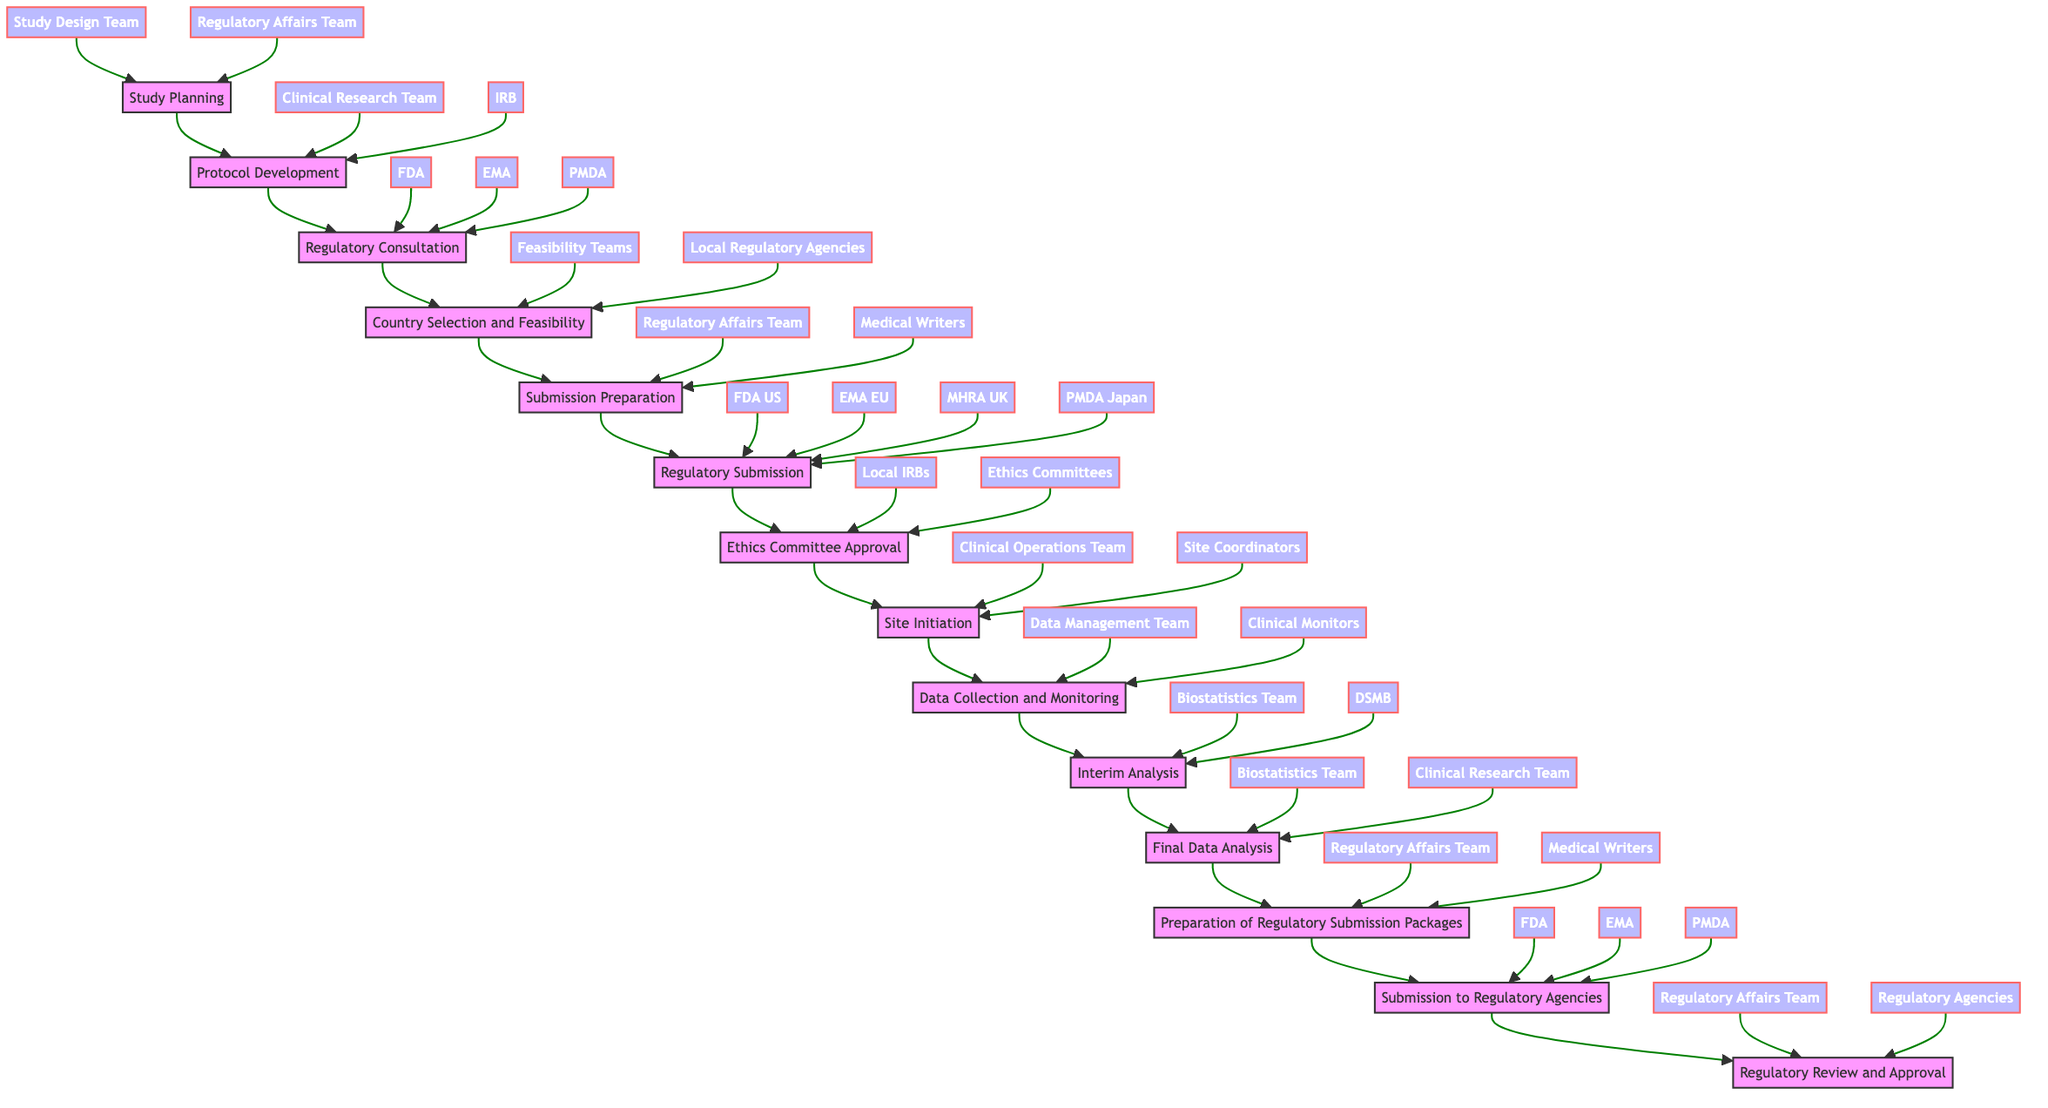What is the first action in the workflow? The first action in the workflow is "Define objectives and endpoints," which is indicated under "Study Planning."
Answer: Define objectives and endpoints How many entities are involved in the "Regulatory Consultation"? The diagram shows three entities involved in the "Regulatory Consultation," which are FDA, EMA, and PMDA.
Answer: Three What follows "Interim Analysis" in the workflow? "Final Data Analysis" directly follows "Interim Analysis" in the flow chart, creating a sequence between the two actions.
Answer: Final Data Analysis Which team is responsible for "Preparation of Regulatory Submission Packages"? The teams responsible for this action are the Regulatory Affairs Team and Medical Writers, as stated in the node for that action.
Answer: Regulatory Affairs Team, Medical Writers Which action comes after "Submission Preparation"? The action "Regulatory Submission" comes directly after "Submission Preparation" in the flow, indicating the order of tasks in the workflow.
Answer: Regulatory Submission What are the two entities involved in "Site Initiation"? The two entities involved are the Clinical Operations Team and Site Coordinators, as noted in the associated node of the workflow.
Answer: Clinical Operations Team, Site Coordinators Who is involved in the final regulatory submission? The final regulatory submission involves the FDA, EMA, and PMDA, as shown in the node for "Submission to Regulatory Agencies."
Answer: FDA, EMA, PMDA What action occurs before "Ethics Committee Approval"? The action that occurs before "Ethics Committee Approval" is "Regulatory Submission," which is the preceding step according to the flowchart.
Answer: Regulatory Submission How many total steps are there in the workflow? The workflow consists of a total of fourteen steps, represented as nodes in the flowchart from "Study Planning" to "Regulatory Review and Approval."
Answer: Fourteen 